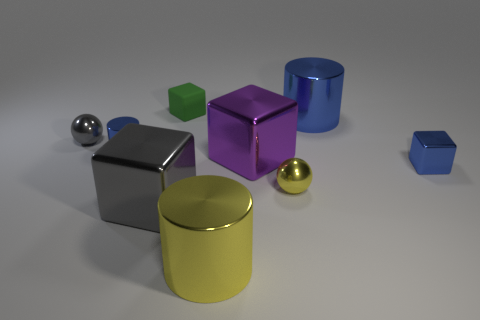Add 1 small cylinders. How many objects exist? 10 Subtract all cylinders. How many objects are left? 6 Subtract all tiny objects. Subtract all big yellow blocks. How many objects are left? 4 Add 5 tiny green things. How many tiny green things are left? 6 Add 8 large purple objects. How many large purple objects exist? 9 Subtract 0 green spheres. How many objects are left? 9 